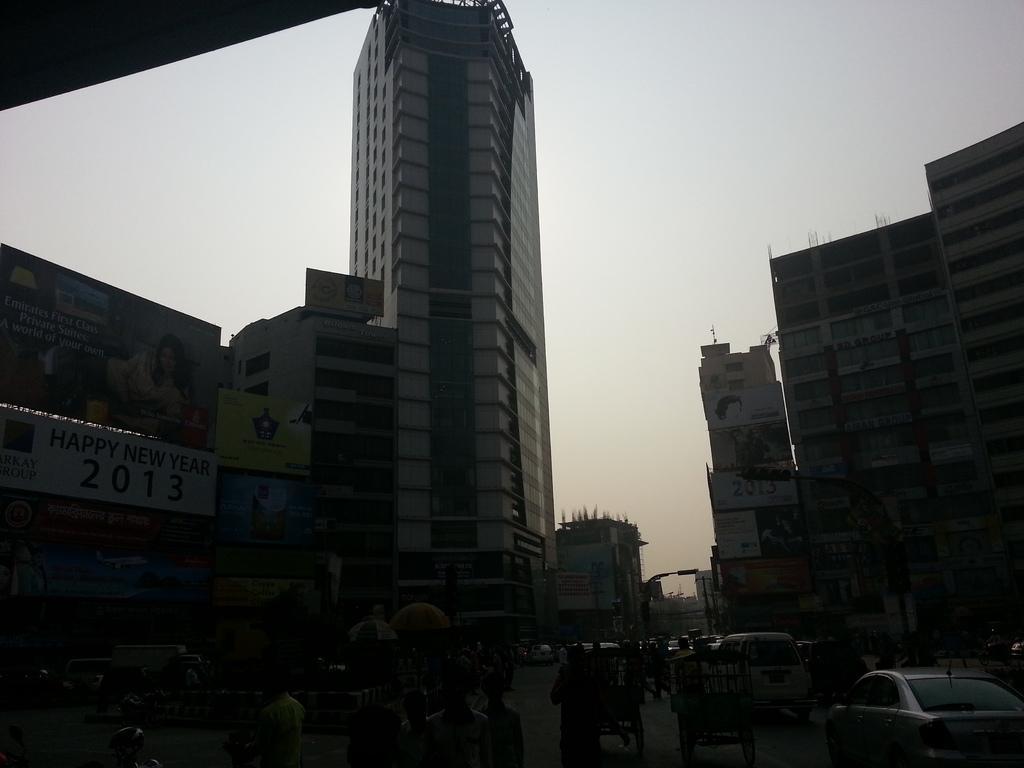Please provide a concise description of this image. There is a road. On the road there are many people, carts and vehicles. On the sides there are buildings and banners. In the background there is sky. 